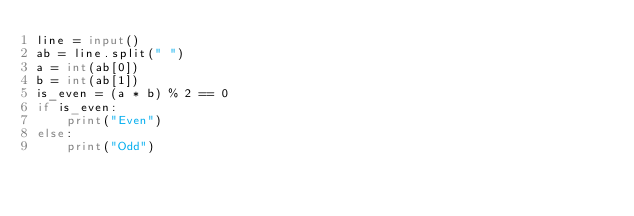Convert code to text. <code><loc_0><loc_0><loc_500><loc_500><_Python_>line = input()
ab = line.split(" ")
a = int(ab[0])
b = int(ab[1])
is_even = (a * b) % 2 == 0
if is_even:
    print("Even")
else:
    print("Odd")
</code> 